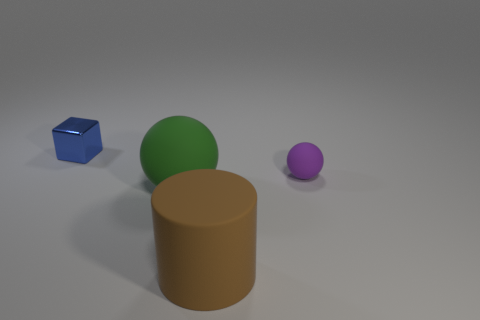Do the cube and the brown rubber object have the same size?
Keep it short and to the point. No. There is a rubber ball that is to the left of the small matte sphere; what is its color?
Keep it short and to the point. Green. Are there any other big cylinders of the same color as the cylinder?
Your answer should be very brief. No. The ball that is the same size as the metallic thing is what color?
Your answer should be compact. Purple. Is the shape of the green thing the same as the purple thing?
Offer a terse response. Yes. There is a tiny thing that is behind the small purple thing; what is its material?
Give a very brief answer. Metal. The tiny block has what color?
Your answer should be very brief. Blue. There is a ball behind the green sphere; is it the same size as the rubber thing that is to the left of the brown thing?
Make the answer very short. No. There is a object that is both behind the big green object and right of the small block; what is its size?
Your response must be concise. Small. There is another object that is the same shape as the purple object; what is its color?
Your answer should be very brief. Green. 